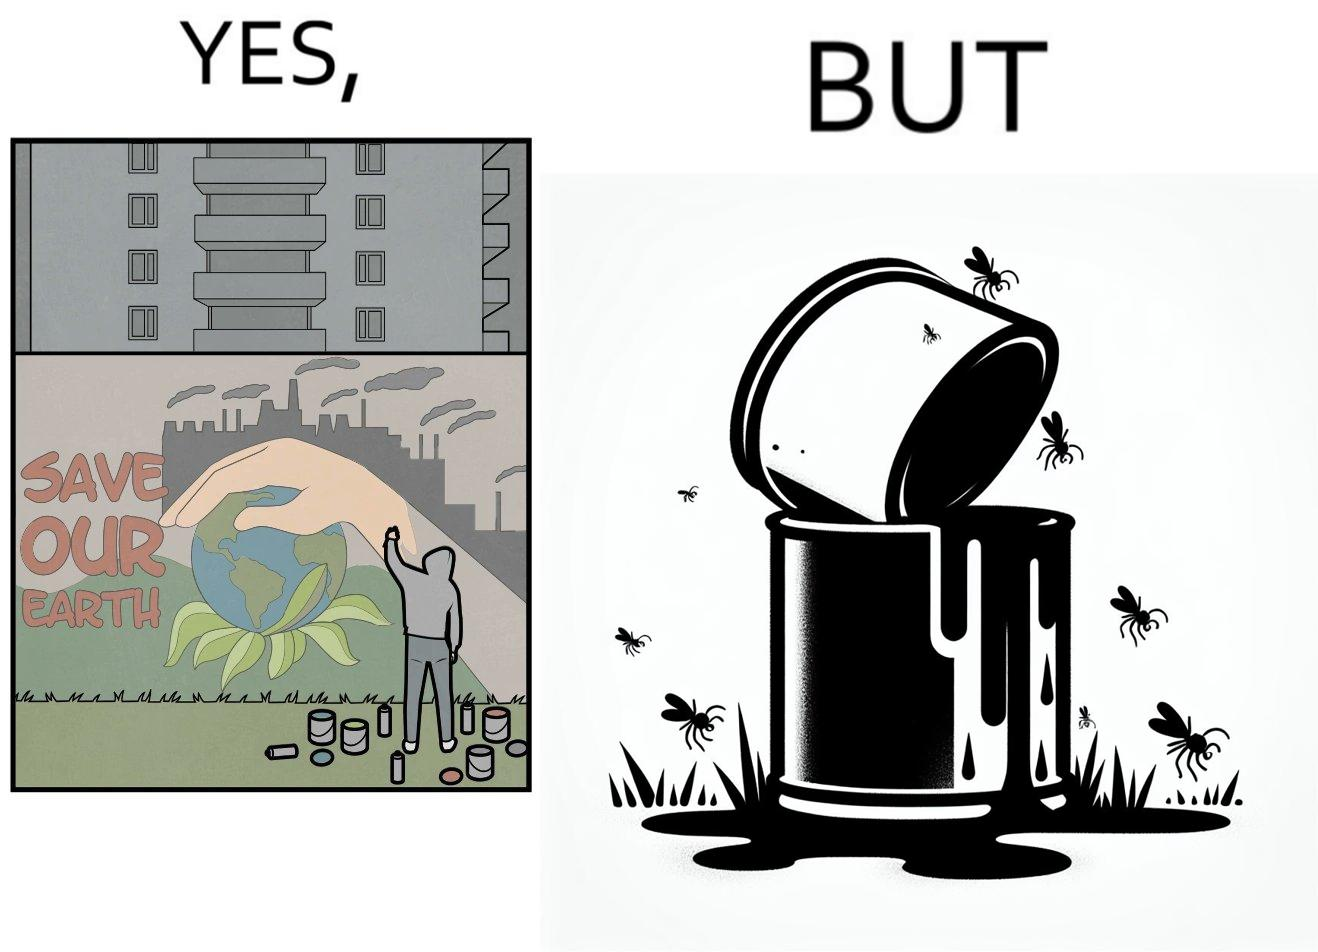Compare the left and right sides of this image. In the left part of the image: A man drawing a graffiti themed "save Our earth". In the right part of the image: A can of paint, overflowing onto the grass. The paint seems to be harmful for insects. 